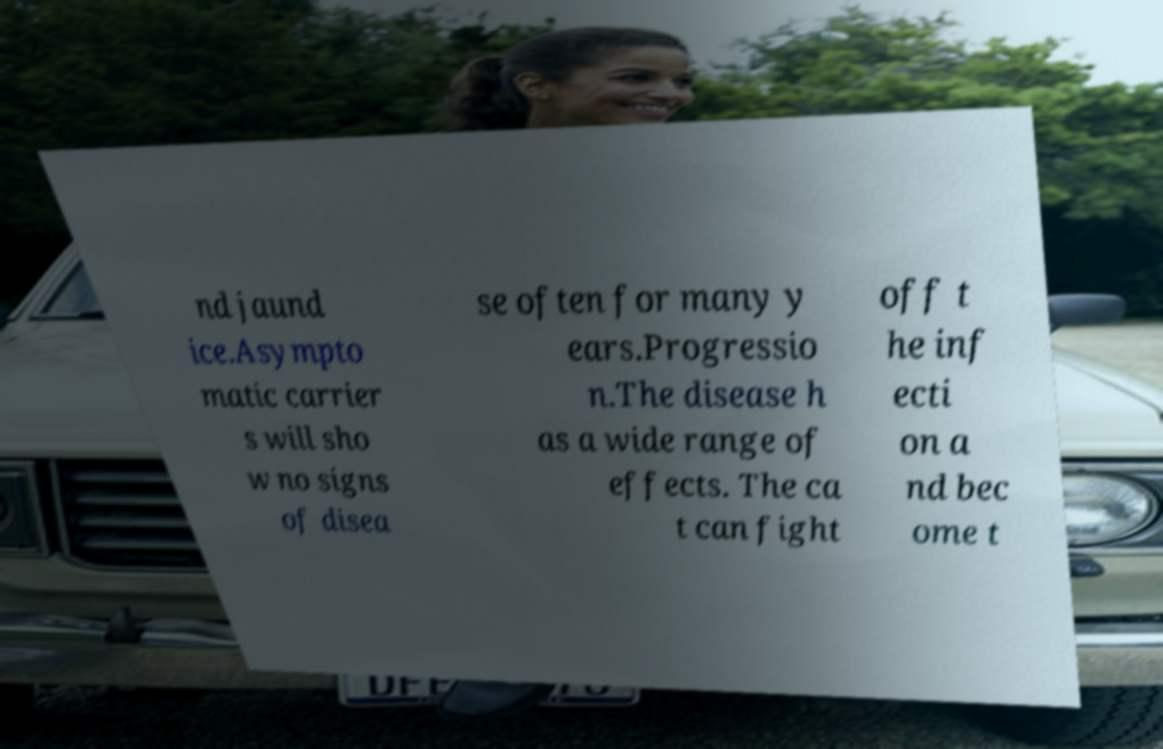Please identify and transcribe the text found in this image. nd jaund ice.Asympto matic carrier s will sho w no signs of disea se often for many y ears.Progressio n.The disease h as a wide range of effects. The ca t can fight off t he inf ecti on a nd bec ome t 